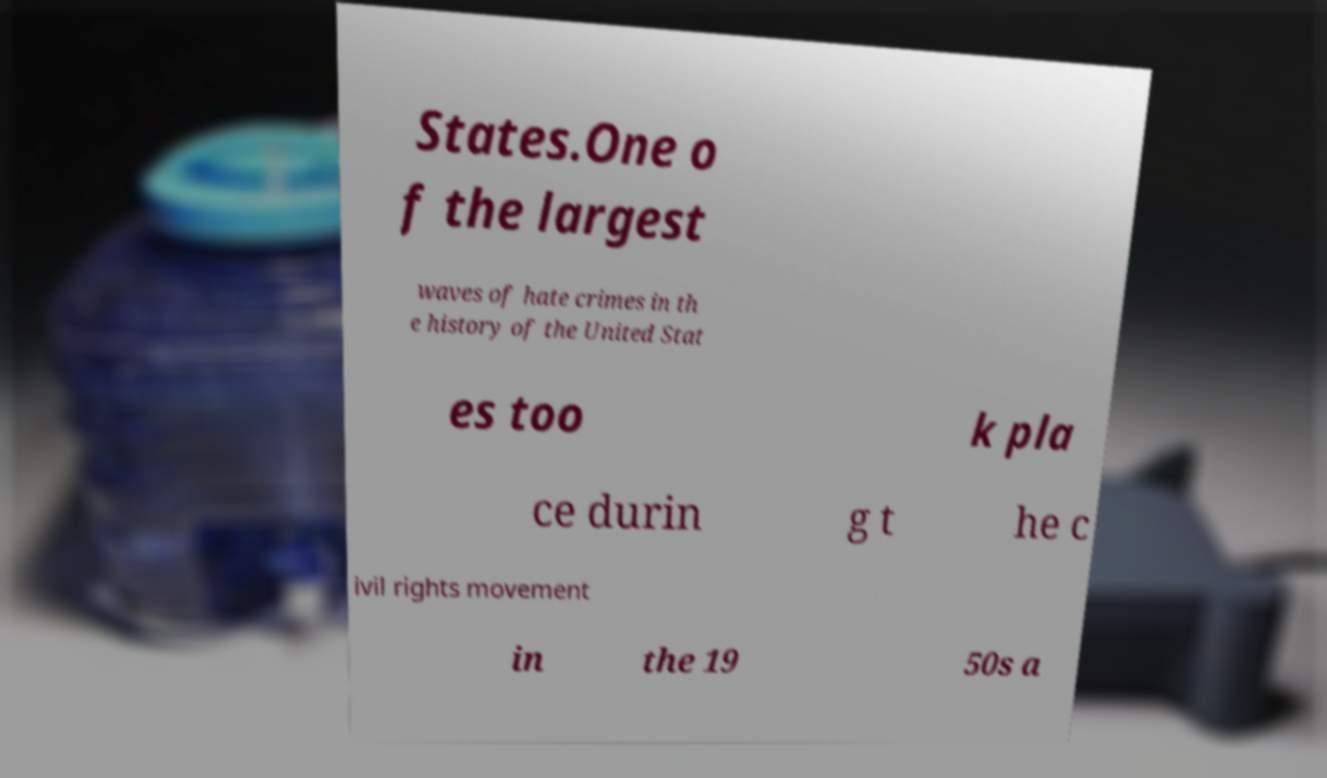Please read and relay the text visible in this image. What does it say? States.One o f the largest waves of hate crimes in th e history of the United Stat es too k pla ce durin g t he c ivil rights movement in the 19 50s a 